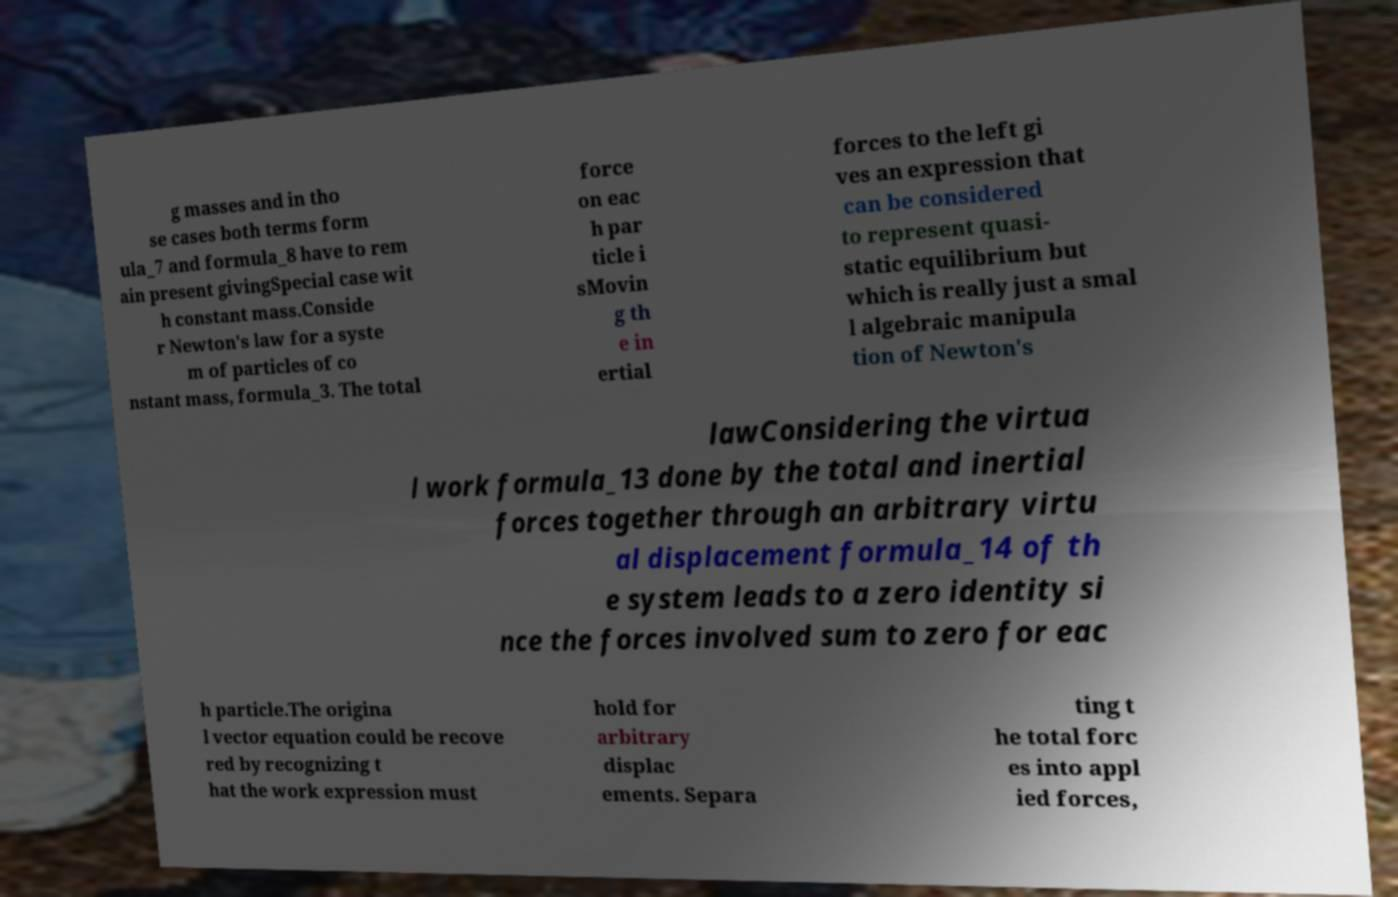For documentation purposes, I need the text within this image transcribed. Could you provide that? g masses and in tho se cases both terms form ula_7 and formula_8 have to rem ain present givingSpecial case wit h constant mass.Conside r Newton's law for a syste m of particles of co nstant mass, formula_3. The total force on eac h par ticle i sMovin g th e in ertial forces to the left gi ves an expression that can be considered to represent quasi- static equilibrium but which is really just a smal l algebraic manipula tion of Newton's lawConsidering the virtua l work formula_13 done by the total and inertial forces together through an arbitrary virtu al displacement formula_14 of th e system leads to a zero identity si nce the forces involved sum to zero for eac h particle.The origina l vector equation could be recove red by recognizing t hat the work expression must hold for arbitrary displac ements. Separa ting t he total forc es into appl ied forces, 